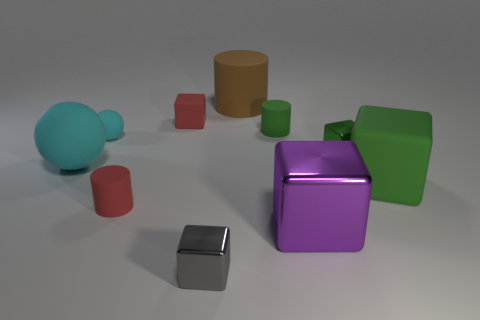Subtract all brown rubber cylinders. How many cylinders are left? 2 Subtract all cylinders. How many objects are left? 7 Subtract 1 spheres. How many spheres are left? 1 Subtract all purple cylinders. How many green blocks are left? 2 Add 2 small objects. How many small objects exist? 8 Subtract all red cubes. How many cubes are left? 4 Subtract 0 purple cylinders. How many objects are left? 10 Subtract all yellow blocks. Subtract all green spheres. How many blocks are left? 5 Subtract all green matte cubes. Subtract all gray objects. How many objects are left? 8 Add 7 tiny gray metallic objects. How many tiny gray metallic objects are left? 8 